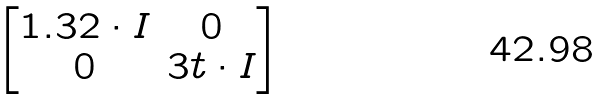Convert formula to latex. <formula><loc_0><loc_0><loc_500><loc_500>\begin{bmatrix} 1 . 3 2 \cdot I & 0 \\ 0 & 3 t \cdot I \end{bmatrix}</formula> 